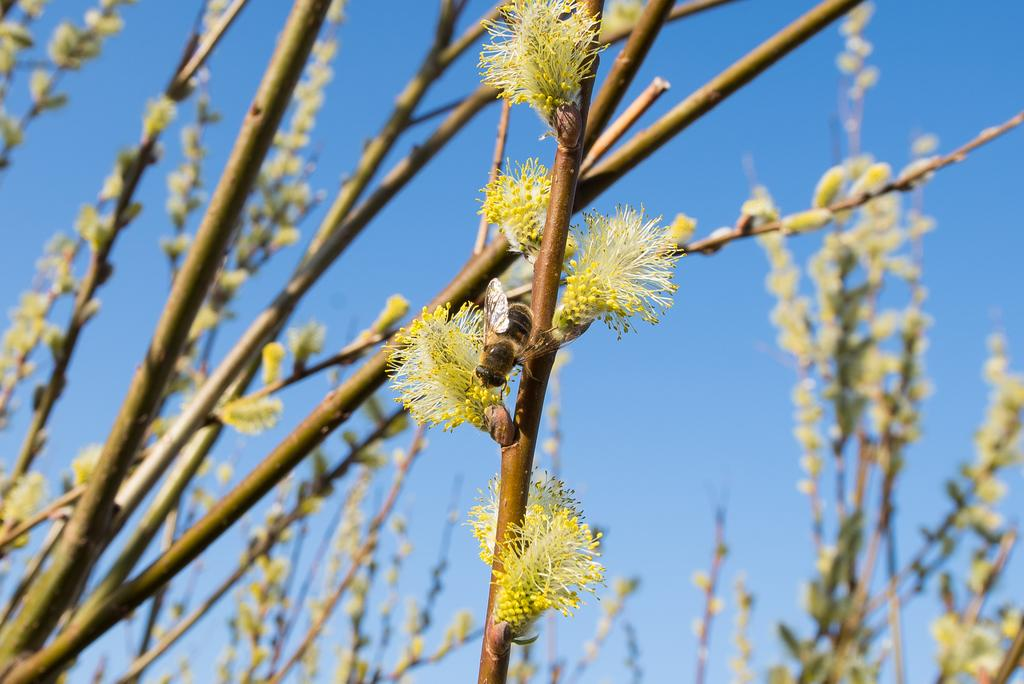What type of plants are in the image? There are plants with flowers in the image. Can you describe the part of the plant that is holding the flowers? There is a stem with flowers in the image. What is present on the stem in the image? There is an insect on the stem in the image. What can be seen in the background of the image? The sky is visible in the background of the image. What type of hot dish is being prepared in the image? There is no hot dish being prepared in the image; it features plants with flowers, a stem, an insect, and the sky in the background. 